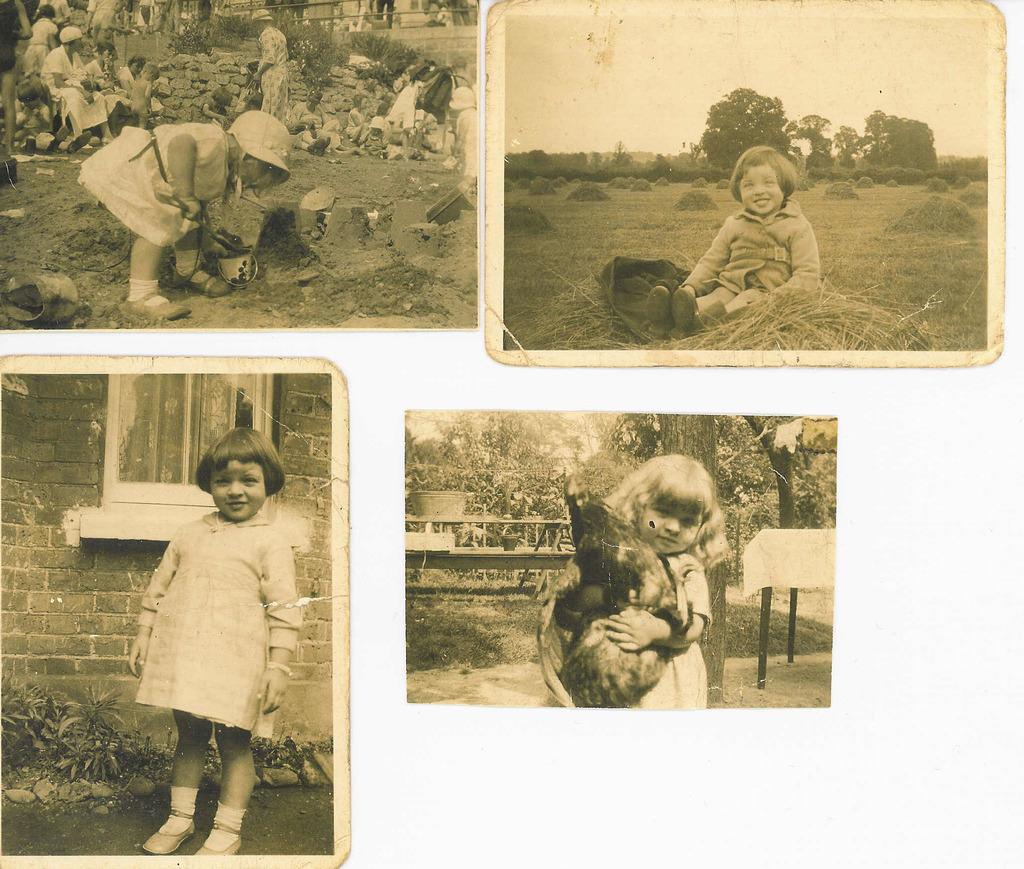What type of objects can be seen in the image? There are photos in the image. What can be found in the photos? The photos contain images of people. What type of structure is present in the image? There is a stone wall in the image. What else can be seen in the image besides the photos and stone wall? There are plants in the image. What type of nail is being used to hang the photos in the image? There is no nail visible in the image, and the photos are not shown hanging on a wall. What type of lettuce can be seen growing among the plants in the image? There is no lettuce present in the image; only plants are visible. 